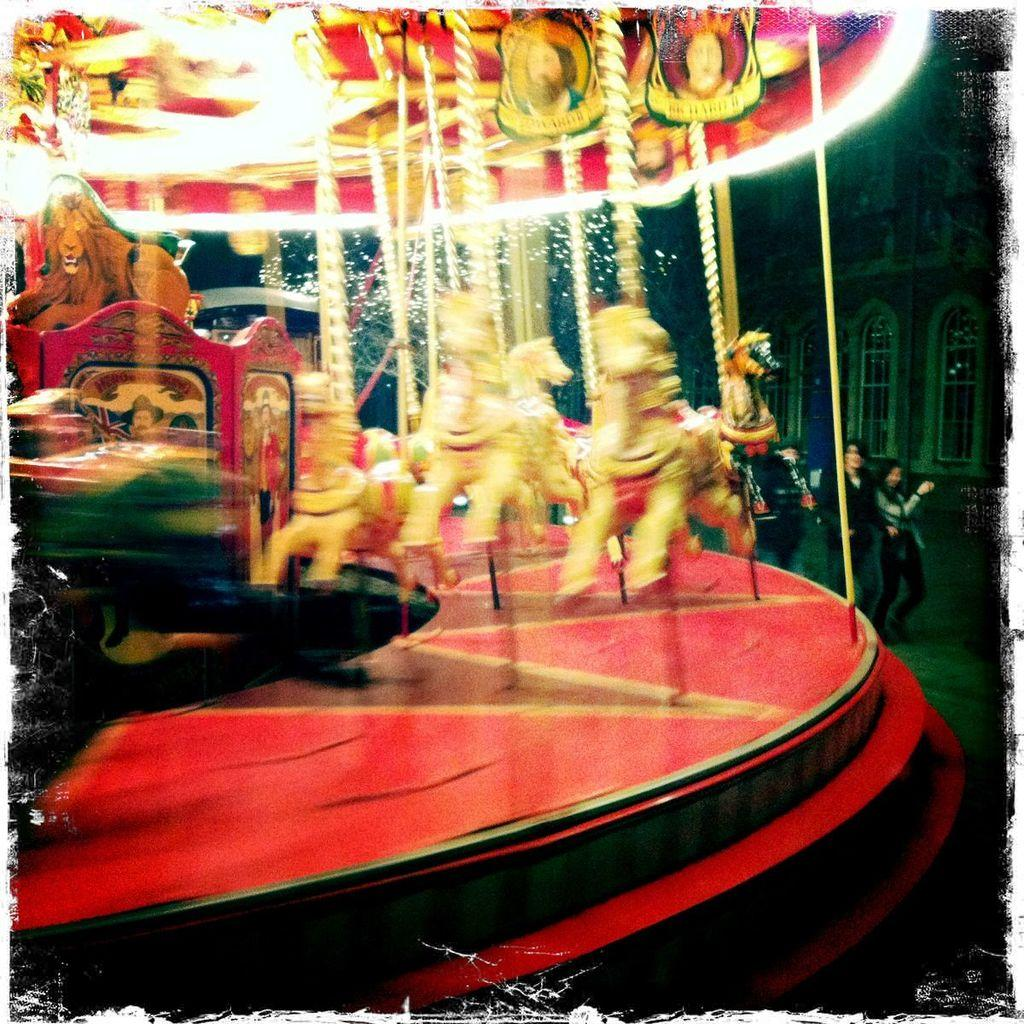What is the overall quality of the image? The image is blurred. What can be seen on the left side of the image? There is a child carousel on the left side of the image. What is happening on the right side of the image? There are people walking on the right side of the image. What can be seen in the background of the image? There is a building in the background of the image. How many rabbits are hopping on the carousel in the image? A: There are no rabbits present in the image; it features a child carousel with people walking nearby. What level of the building is visible in the image? The image does not show a specific level of the building; it only shows the building in the background. 